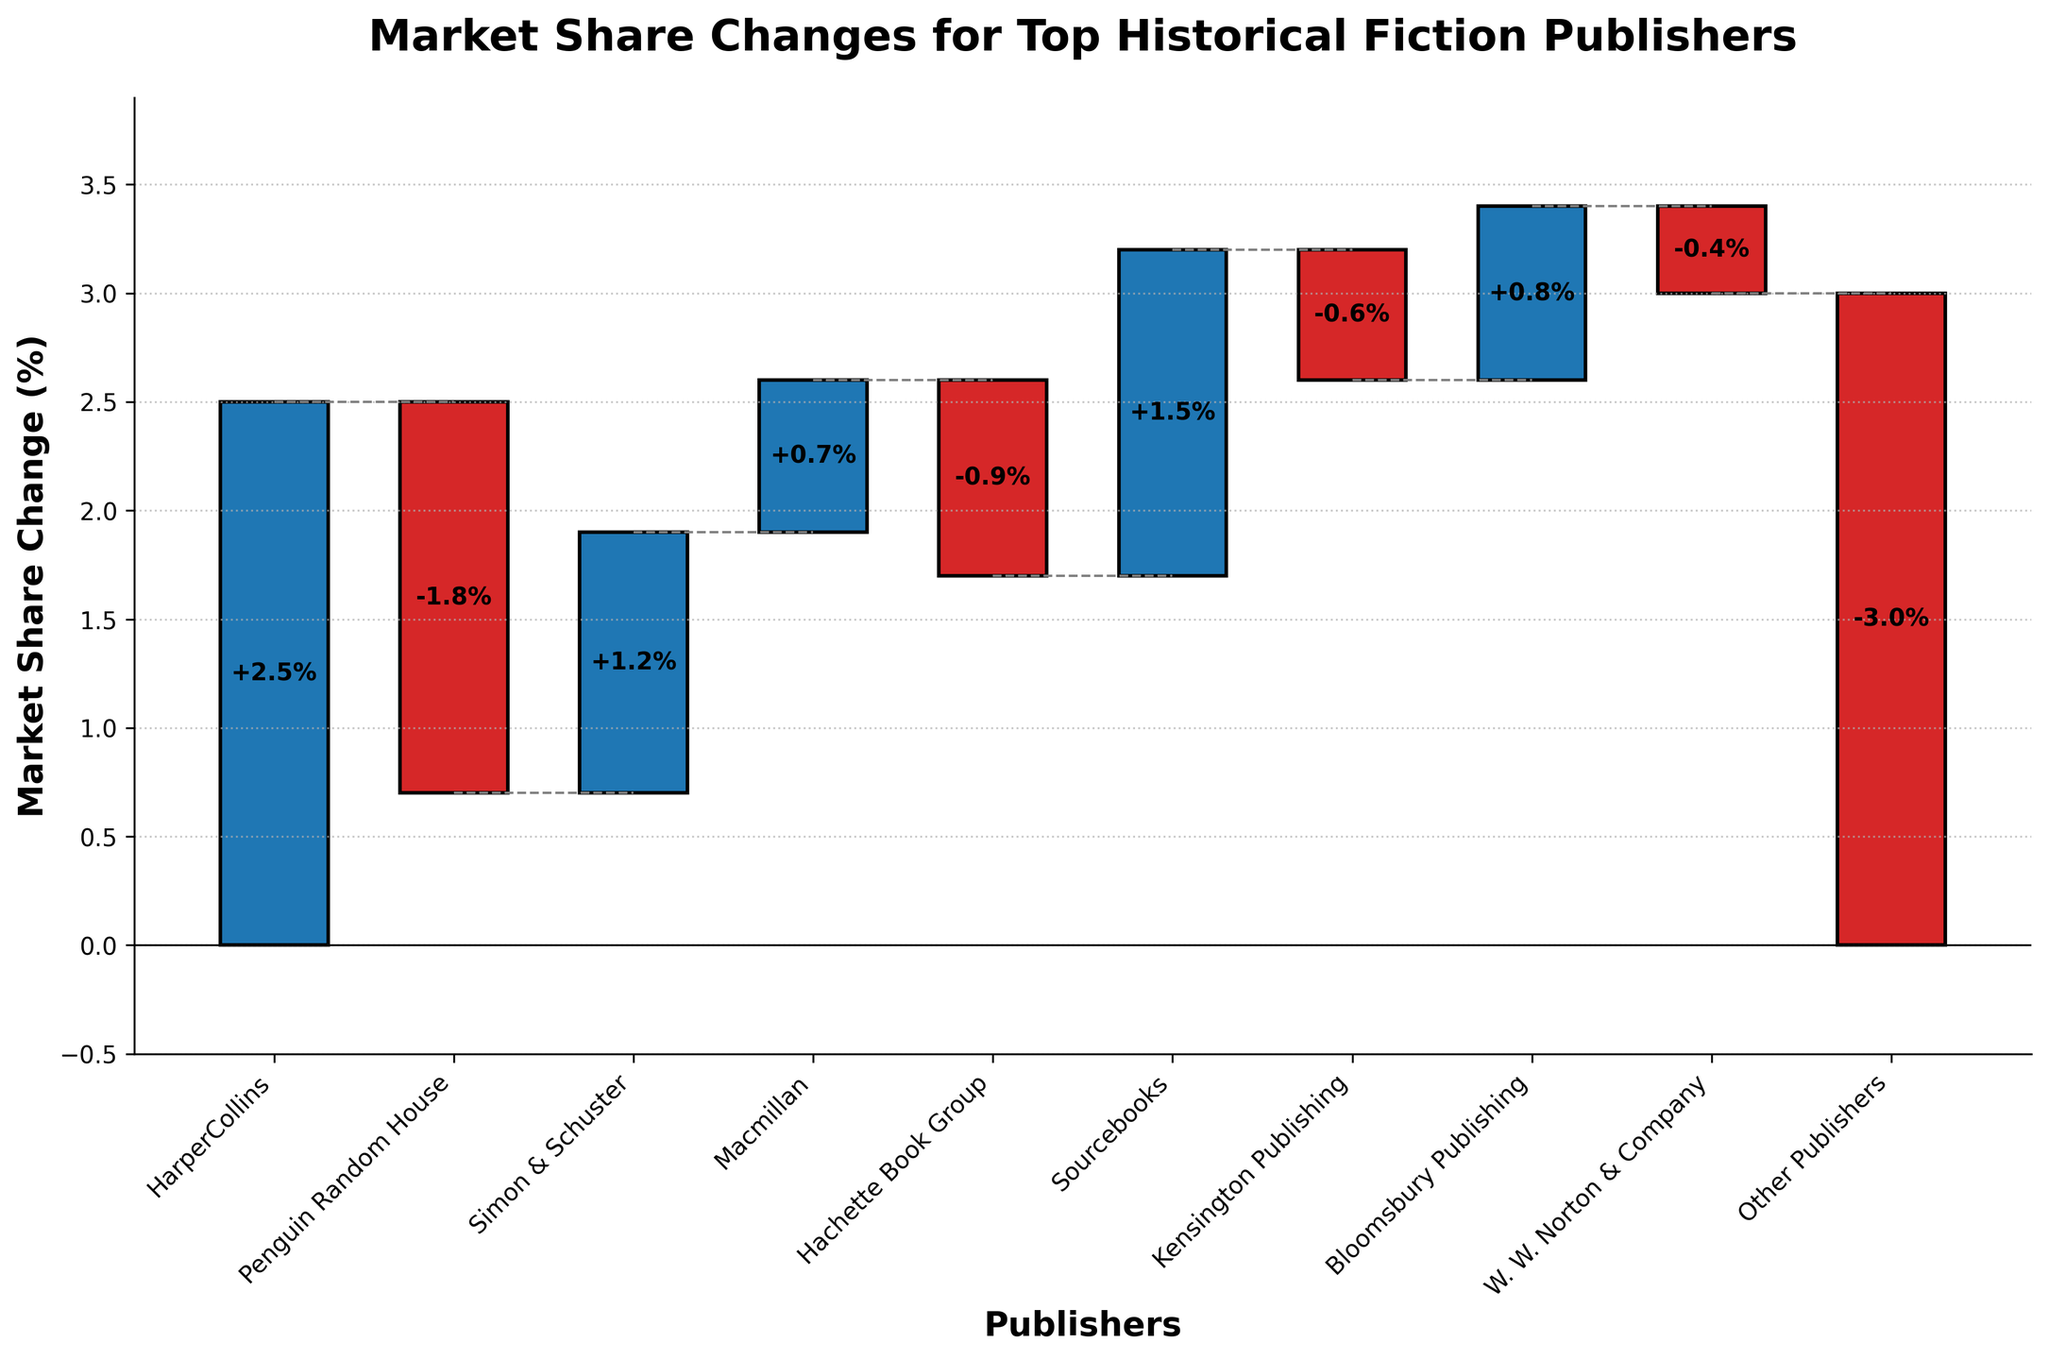What's the title of the chart? The title is displayed at the top of the chart and it usually summarizes the main topic of the visual representation. Here, the title shown is "Market Share Changes for Top Historical Fiction Publishers".
Answer: Market Share Changes for Top Historical Fiction Publishers How many publishers gained market share? To determine this, look for the bars that extend upwards from the baseline. Positive values are indicated by bars in blue. Count these bars. The publishers HarperCollins, Simon & Schuster, Macmillan, Sourcebooks, and Bloomsbury Publishing experienced gains.
Answer: 5 Which publisher had the largest increase in market share? Find the bar with the largest positive value by seeing which bar extends the highest from its starting point. HarperCollins has an increase of +2.5%.
Answer: HarperCollins What is the total market share loss by all publishers combined? Identify the negative changes (red bars). Sum these values: Penguin Random House (-1.8%) + Hachette Book Group (-0.9%) + Kensington Publishing (-0.6%) + W. W. Norton & Company (-0.4%) + Other Publishers (-3.0%). The sum of market share losses is 1.8 + 0.9 + 0.6 + 0.4 + 3.0.
Answer: 6.7% How much market share does Simon & Schuster gain compared to Sourcebooks? Look at the bars for both publishers. Simon & Schuster gained +1.2% and Sourcebooks gained +1.5%. Subtract the smaller gain from the larger gain: 1.5% - 1.2%.
Answer: 0.3% Which publishers have a market share change less than 1%? Examine the heights of the bars and check the values below 1%: Hachette Book Group (-0.9%), Kensington Publishing (-0.6%), W. W. Norton & Company (-0.4%), Macmillan (+0.7%), and Bloomsbury Publishing (+0.8%).
Answer: Hachette Book Group, Kensington Publishing, W. W. Norton & Company, Macmillan, Bloomsbury Publishing What is the cumulative market share change for HarperCollins, Penguin Random House, and Simon & Schuster? Add up the individual changes for these publishers: HarperCollins (+2.5%), Penguin Random House (-1.8%), and Simon & Schuster (+1.2%). The cumulative change is 2.5 + (-1.8) + 1.2.
Answer: +1.9% How does the market share change for Bloomsbury Publishing compare with W. W. Norton & Company? Bloomsbury Publishing has a bar extending upwards (+0.8%) and W. W. Norton & Company has a downward bar (-0.4%). Bloomsbury's gain is larger than W. W. Norton's loss.
Answer: Bloomsbury Publishing has a higher gain Based on the figure, which data point indicates the largest negative market share change? Identify the tallest red bar, indicating the largest loss. Other Publishers have the largest decline at -3.0%.
Answer: Other Publishers 